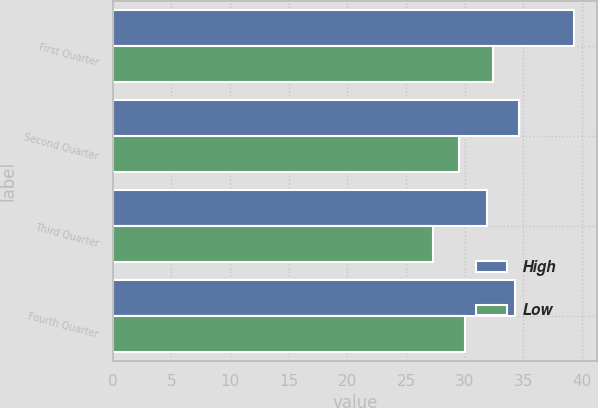Convert chart to OTSL. <chart><loc_0><loc_0><loc_500><loc_500><stacked_bar_chart><ecel><fcel>First Quarter<fcel>Second Quarter<fcel>Third Quarter<fcel>Fourth Quarter<nl><fcel>High<fcel>39.33<fcel>34.65<fcel>31.89<fcel>34.27<nl><fcel>Low<fcel>32.4<fcel>29.54<fcel>27.26<fcel>30.02<nl></chart> 